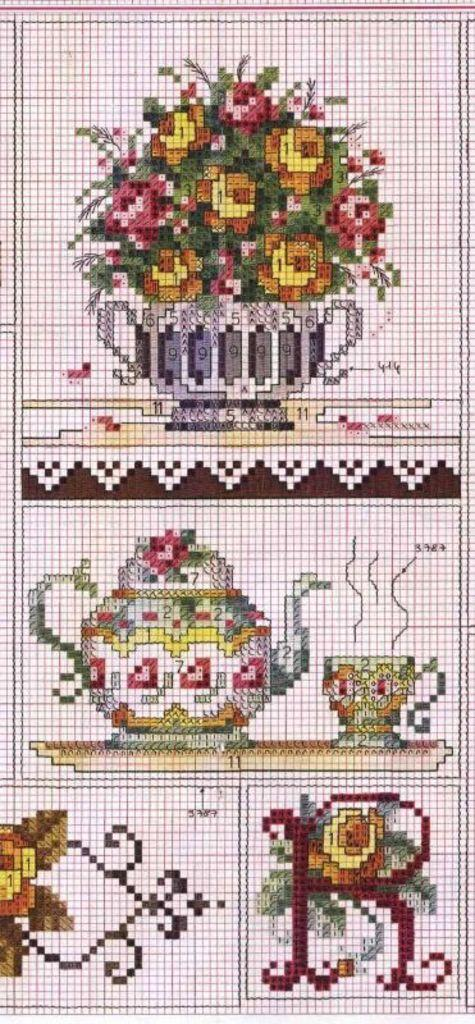What type of plant can be seen in the image? There is a houseplant in the image. What is the other main object in the image? There is a teapot in the image. Can you describe any other objects in the image? There are some unspecified objects in the image. What type of fish can be seen swimming in the image? There are no fish present in the image; it features a houseplant and a teapot. How many steps are visible in the image? There is no mention of steps in the image; it only includes a houseplant, a teapot, and some unspecified objects. 